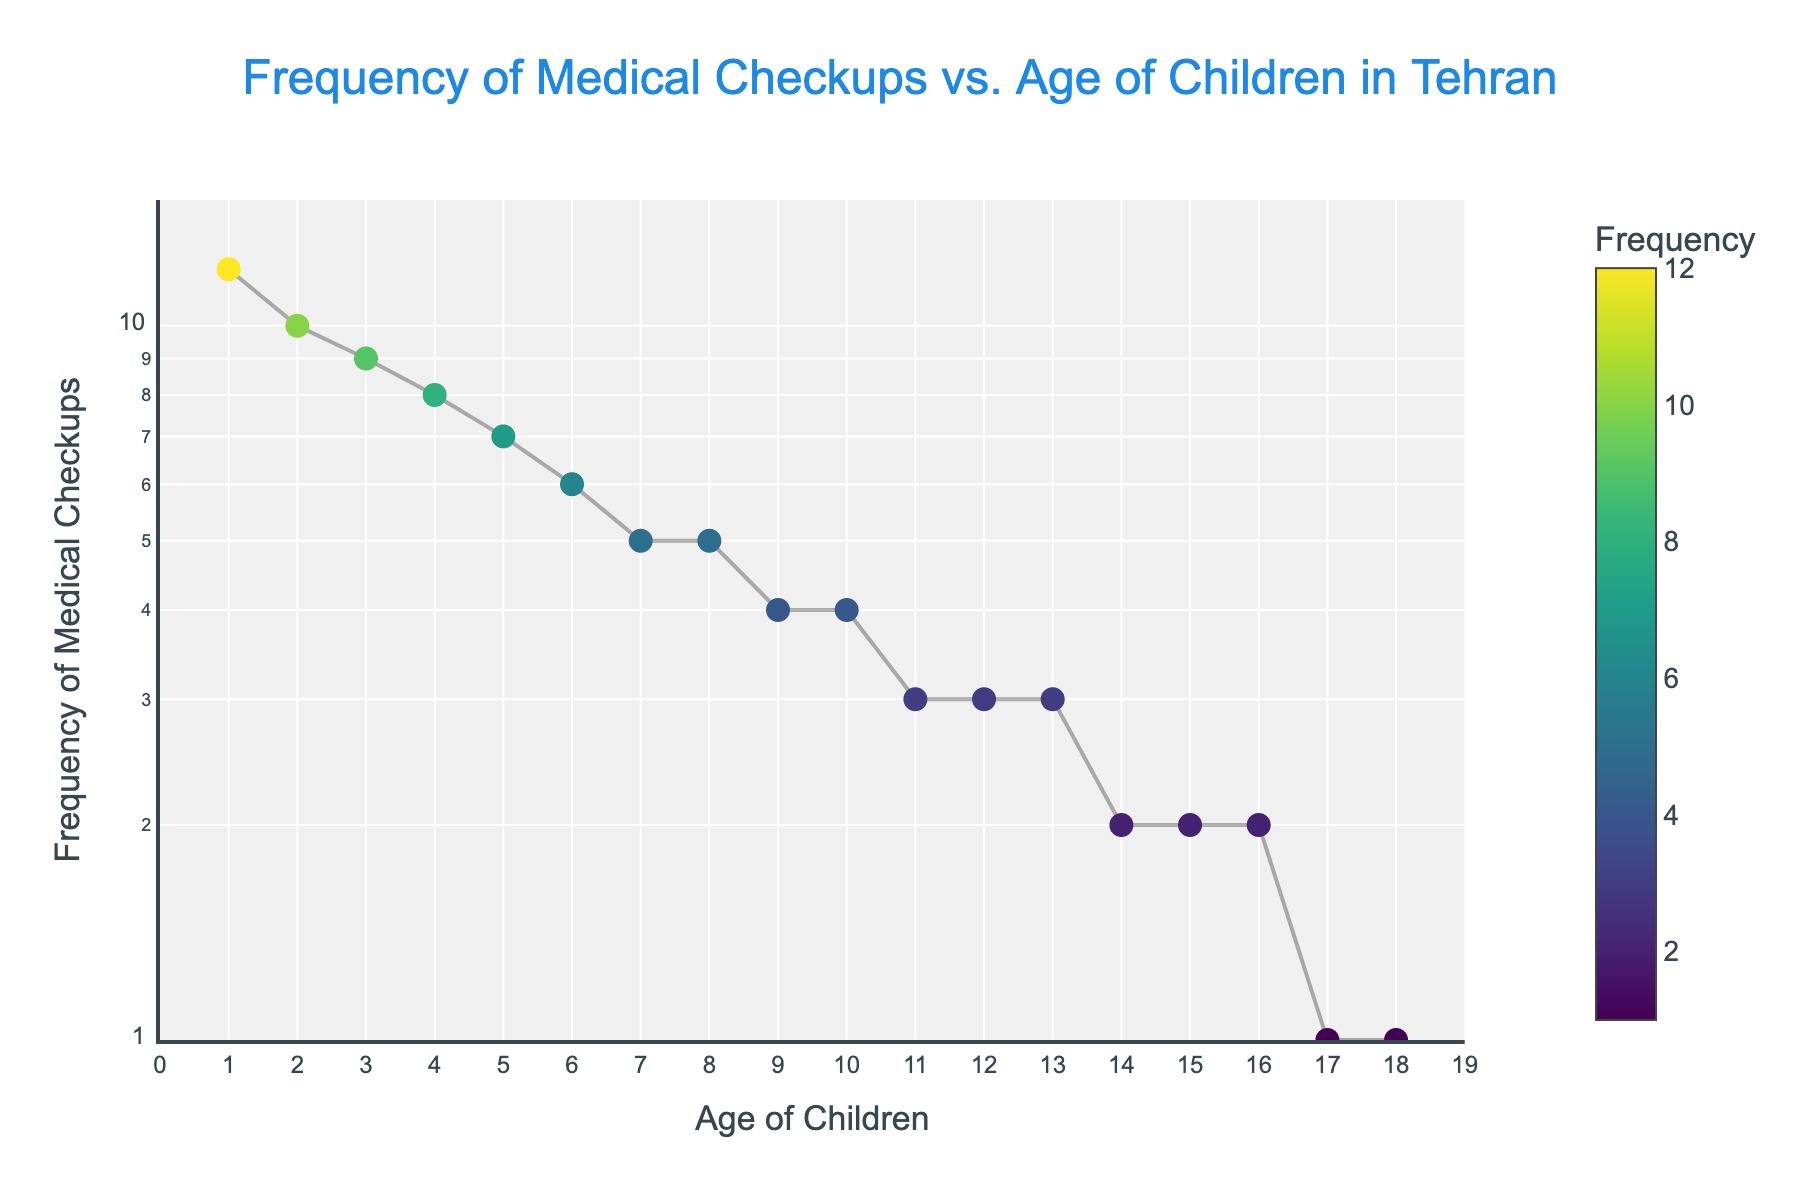What is the title of the figure? The title is clearly displayed at the top of the figure. It reads, "Frequency of Medical Checkups vs. Age of Children in Tehran".
Answer: Frequency of Medical Checkups vs. Age of Children in Tehran What are the axes labels? The labels are near the respective axes. The x-axis is labeled "Age of Children", and the y-axis is labeled "Frequency of Medical Checkups".
Answer: Age of Children; Frequency of Medical Checkups How many data points are there in the figure? Each dot represents a data point, and counting them gives us a total of 18.
Answer: 18 At what age do children have the highest frequency of medical checkups? By looking at the y-values of the scatter plot, the highest frequency appears at age 1.
Answer: 1 How does the frequency of medical checkups change from age 1 to age 18? Observing the trend in the scatter plot, the frequency decreases as the age increases.
Answer: Decreases What is the median frequency of medical checkups for children aged 3 to 10? List the frequency values for ages 3 to 10: (9, 8, 7, 6, 5, 4, 3, 3), and find the middle value(s). The median is the average of the two middle values (6+5)/2 = 5.5.
Answer: 5.5 What is the total frequency of medical checkups for children aged 6 and 7? Add the values for ages 6 (6 checkups) and 7 (5 checkups), which equals 6 + 5 = 11.
Answer: 11 At what ages do children have the least frequent medical checkups? From the y-axis values, ages 17 and 18 have the lowest frequency, which is 1 checkup.
Answer: 17 and 18 How does the log scale affect the y-axis in the plot? The log scale changes how evenly the intervals are distributed on the y-axis; it makes a wide range of frequencies more interpretable.
Answer: More interpretable Which age group experienced the largest drop in the frequency of medical checkups between consecutive years? Compare the differences in frequency between consecutive ages. The largest drop is from age 1 to age 2 (12 - 10 = 2).
Answer: 1 to 2 